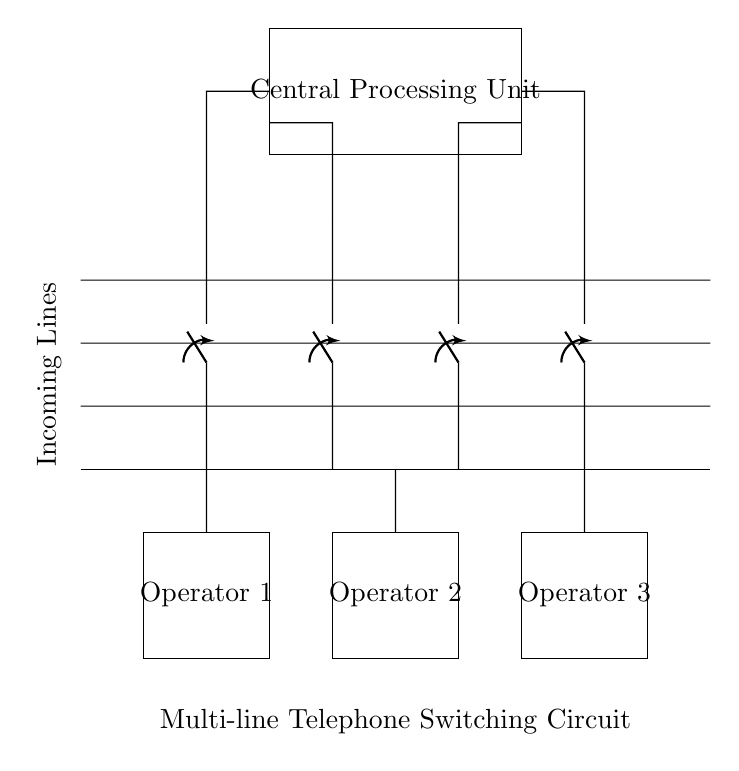What is the main component that manages incoming calls? The Central Processing Unit is responsible for managing the call switching process between the incoming lines and operator stations.
Answer: Central Processing Unit How many operator stations are present in the circuit? The diagram shows three distinct operator stations labeled Operator 1, Operator 2, and Operator 3, which handle the incoming calls.
Answer: Three What do the switches in the circuit represent? The switches act as control devices that allow operators to manage which incoming line is connected to their station, thus providing a means to handle multiple calls effectively.
Answer: Switches Which direction do the incoming lines signal flow? The incoming lines at the top of the diagram connect downward to the switches, indicating that the signals flow from the incoming lines towards the operators.
Answer: Downward How many incoming lines does the circuit have? The presence of four parallel lines indicates the number of incoming calls that can be managed simultaneously within the circuit.
Answer: Four What function does the Central Processing Unit serve in this circuit? The Central Processing Unit integrates the signals from the incoming lines and directs them to the respective operator stations, facilitating efficient communication management.
Answer: Signal management What is the placement of the operator stations in relation to the incoming lines? The operator stations are positioned lower than the incoming lines, indicating they receive signals from those lines, allowing operators to handle calls effectively.
Answer: Lower 